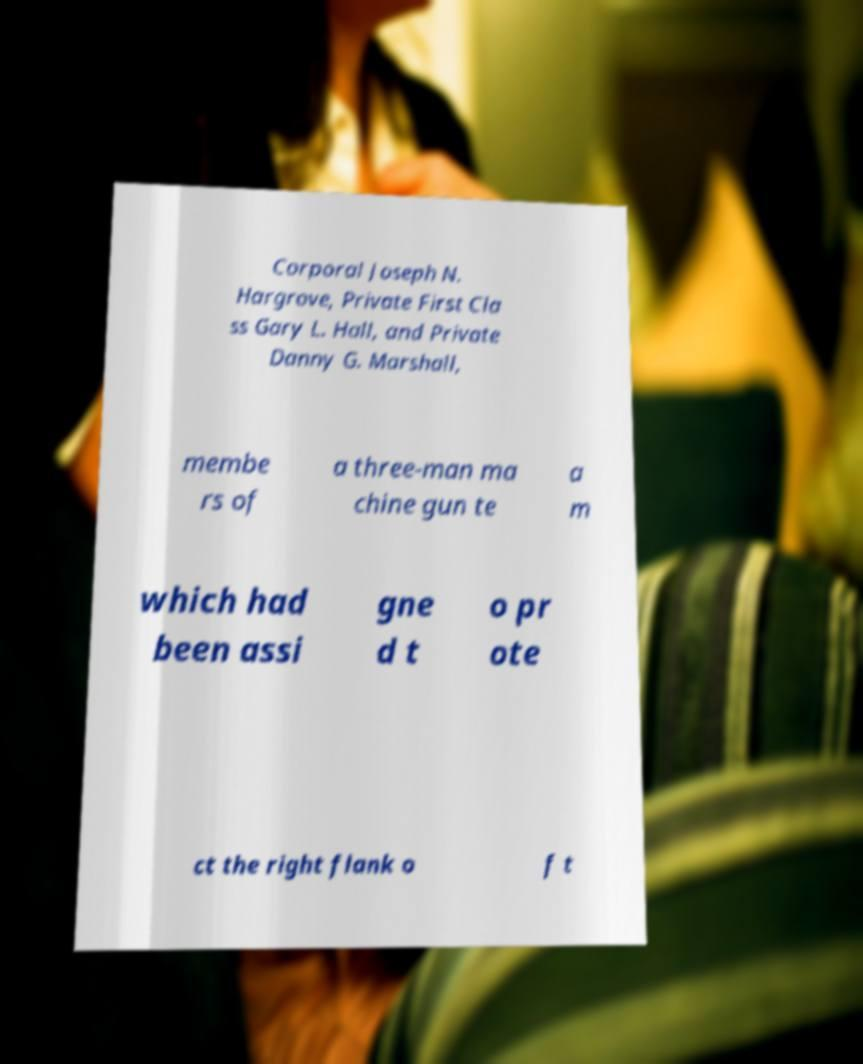Can you accurately transcribe the text from the provided image for me? Corporal Joseph N. Hargrove, Private First Cla ss Gary L. Hall, and Private Danny G. Marshall, membe rs of a three-man ma chine gun te a m which had been assi gne d t o pr ote ct the right flank o f t 